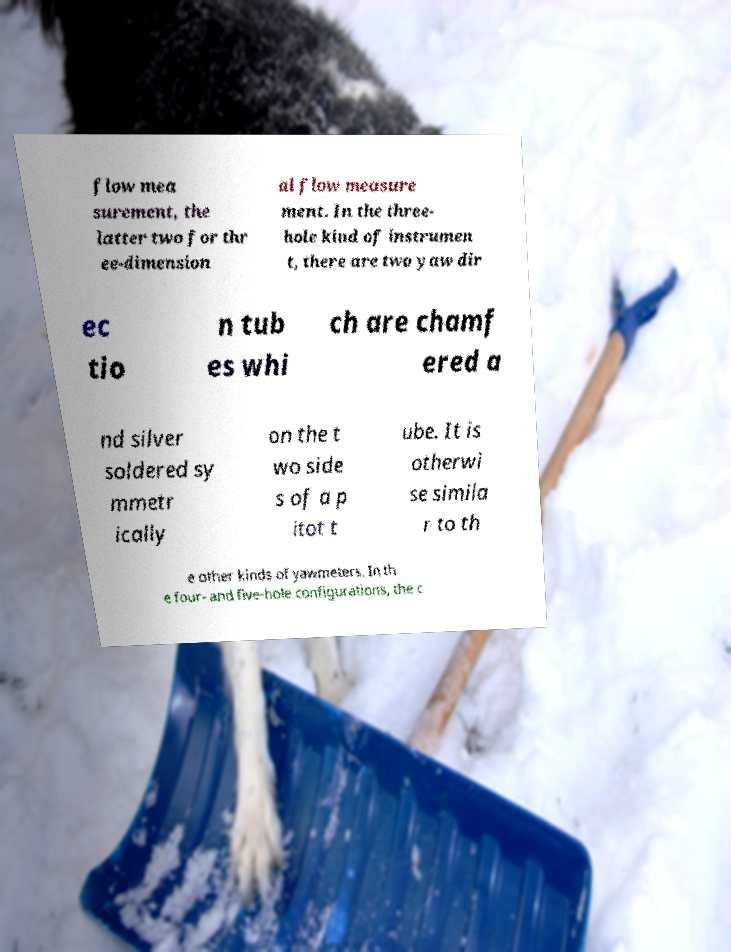Can you accurately transcribe the text from the provided image for me? flow mea surement, the latter two for thr ee-dimension al flow measure ment. In the three- hole kind of instrumen t, there are two yaw dir ec tio n tub es whi ch are chamf ered a nd silver soldered sy mmetr ically on the t wo side s of a p itot t ube. It is otherwi se simila r to th e other kinds of yawmeters. In th e four- and five-hole configurations, the c 